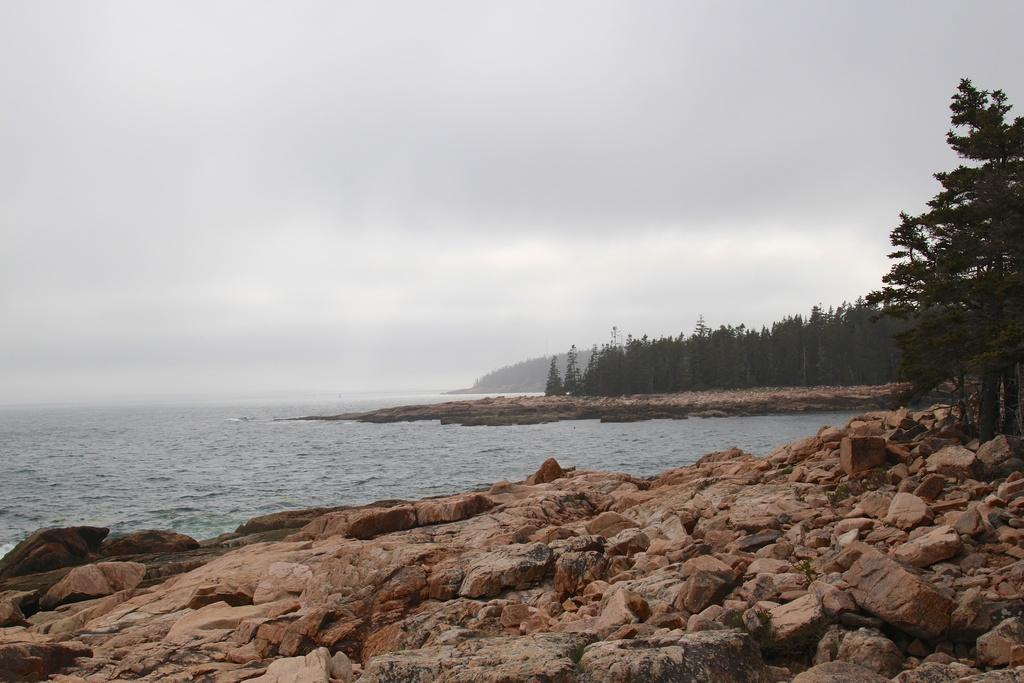What type of objects are located at the bottom of the image? There are stones at the bottom of the image. What natural feature can be seen on the left side of the image? There is a sea on the left side of the image. What type of vegetation is on the right side of the image? There are trees on the right side of the image. What is visible at the top of the image? The sky is visible at the top of the image. Can you tell me how many windows are visible on the train in the image? There is no train present in the image, so it is not possible to determine the number of windows. What type of arithmetic problem is being solved by the partner in the image? There is no partner or arithmetic problem present in the image. 